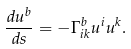<formula> <loc_0><loc_0><loc_500><loc_500>\frac { d u ^ { b } } { d s } = - \Gamma _ { i k } ^ { b } u ^ { i } u ^ { k } .</formula> 